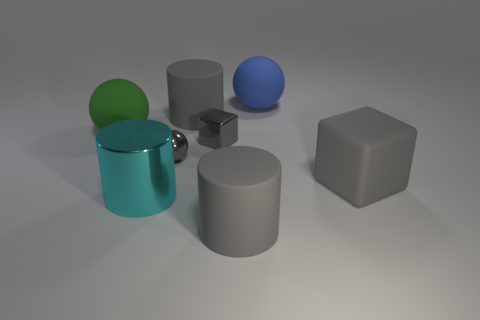There is a shiny ball; is it the same color as the cube left of the large blue rubber sphere?
Make the answer very short. Yes. What number of objects are big gray cylinders behind the cyan shiny cylinder or things that are in front of the tiny sphere?
Keep it short and to the point. 4. What material is the cyan thing that is the same size as the green rubber ball?
Ensure brevity in your answer.  Metal. How many other things are there of the same material as the cyan object?
Offer a very short reply. 2. There is a gray rubber object that is in front of the cyan metal thing; does it have the same shape as the large gray object behind the big matte block?
Give a very brief answer. Yes. What is the color of the rubber thing left of the gray matte thing behind the green ball to the left of the gray shiny sphere?
Keep it short and to the point. Green. What number of other objects are the same color as the metal cylinder?
Your response must be concise. 0. Is the number of tiny gray objects less than the number of gray metallic balls?
Keep it short and to the point. No. There is a matte object that is both in front of the big green sphere and behind the metallic cylinder; what is its color?
Make the answer very short. Gray. What material is the tiny gray object that is the same shape as the blue object?
Offer a very short reply. Metal. 